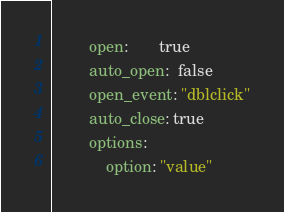Convert code to text. <code><loc_0><loc_0><loc_500><loc_500><_YAML_>        open:       true
        auto_open:  false
        open_event: "dblclick"
        auto_close: true
        options:
            option: "value"
</code> 